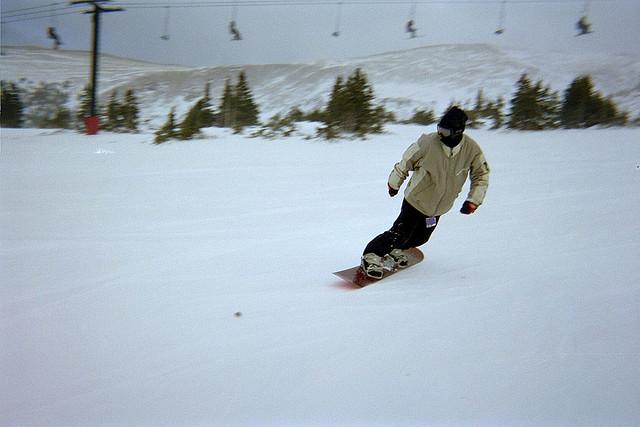What is on the man's face?
Write a very short answer. Mask. Is the snowboarder wearing red gloves?
Concise answer only. Yes. How is this man getting down the mountain?
Be succinct. Snowboard. What color is his board?
Write a very short answer. Brown. What kind of cold weather accessories does the person wear?
Concise answer only. Jacket, snow pants, gloves,. What is this man doing?
Concise answer only. Snowboarding. What trick is the man doing?
Short answer required. Snowboarding. What is the person on?
Answer briefly. Snowboard. Is this person's boot still attached to his board?
Write a very short answer. Yes. Are there people on the ski lift?
Be succinct. Yes. 